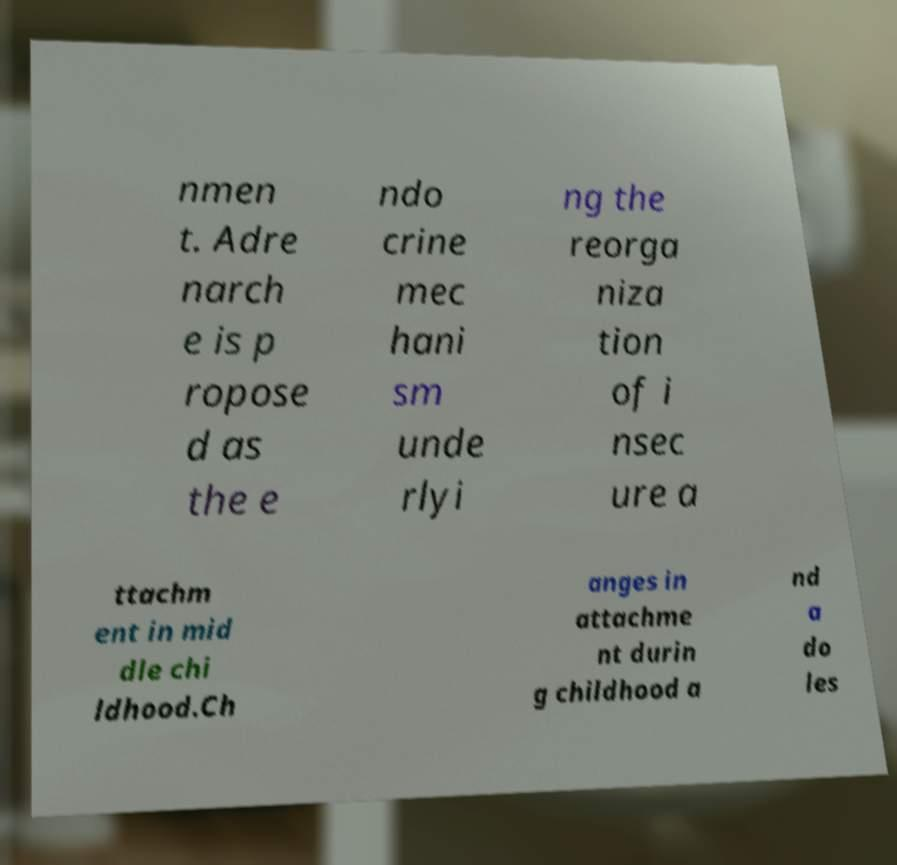For documentation purposes, I need the text within this image transcribed. Could you provide that? nmen t. Adre narch e is p ropose d as the e ndo crine mec hani sm unde rlyi ng the reorga niza tion of i nsec ure a ttachm ent in mid dle chi ldhood.Ch anges in attachme nt durin g childhood a nd a do les 